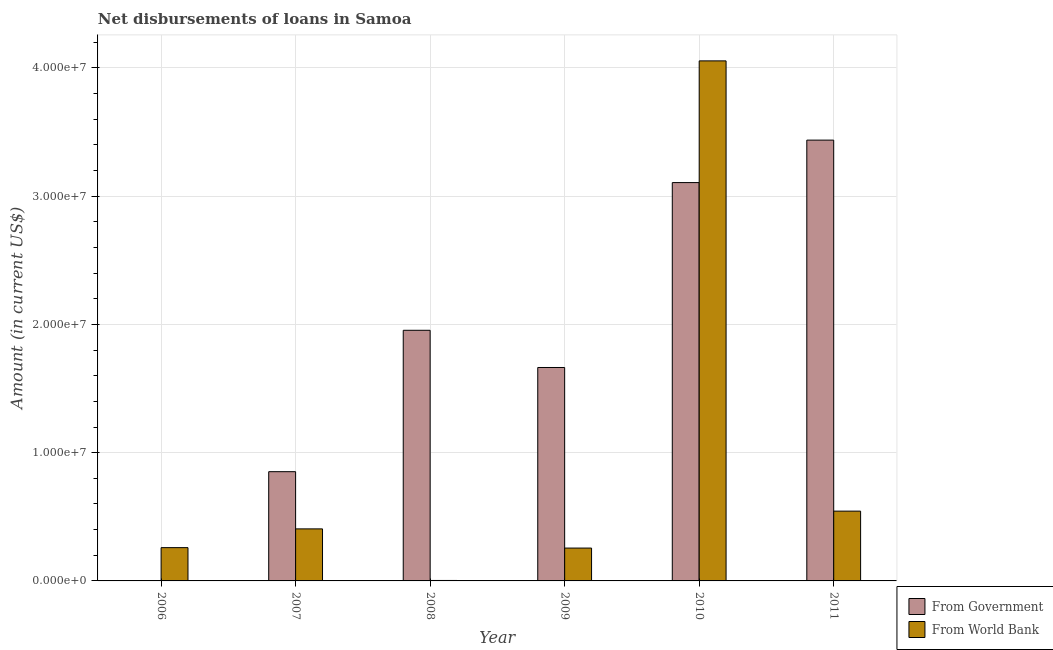Are the number of bars on each tick of the X-axis equal?
Make the answer very short. No. How many bars are there on the 1st tick from the right?
Provide a succinct answer. 2. What is the label of the 3rd group of bars from the left?
Make the answer very short. 2008. What is the net disbursements of loan from world bank in 2006?
Make the answer very short. 2.60e+06. Across all years, what is the maximum net disbursements of loan from world bank?
Keep it short and to the point. 4.05e+07. What is the total net disbursements of loan from world bank in the graph?
Provide a succinct answer. 5.52e+07. What is the difference between the net disbursements of loan from world bank in 2006 and that in 2009?
Offer a very short reply. 3.40e+04. What is the difference between the net disbursements of loan from government in 2010 and the net disbursements of loan from world bank in 2007?
Ensure brevity in your answer.  2.25e+07. What is the average net disbursements of loan from government per year?
Make the answer very short. 1.84e+07. In how many years, is the net disbursements of loan from world bank greater than 32000000 US$?
Your response must be concise. 1. What is the ratio of the net disbursements of loan from world bank in 2007 to that in 2011?
Offer a very short reply. 0.75. Is the net disbursements of loan from world bank in 2006 less than that in 2008?
Your answer should be compact. No. What is the difference between the highest and the second highest net disbursements of loan from world bank?
Your answer should be very brief. 3.51e+07. What is the difference between the highest and the lowest net disbursements of loan from world bank?
Your answer should be compact. 4.05e+07. In how many years, is the net disbursements of loan from government greater than the average net disbursements of loan from government taken over all years?
Offer a terse response. 3. Is the sum of the net disbursements of loan from world bank in 2007 and 2008 greater than the maximum net disbursements of loan from government across all years?
Your answer should be compact. No. Does the graph contain any zero values?
Provide a short and direct response. Yes. How many legend labels are there?
Ensure brevity in your answer.  2. How are the legend labels stacked?
Provide a short and direct response. Vertical. What is the title of the graph?
Offer a terse response. Net disbursements of loans in Samoa. What is the label or title of the X-axis?
Offer a very short reply. Year. What is the Amount (in current US$) in From World Bank in 2006?
Ensure brevity in your answer.  2.60e+06. What is the Amount (in current US$) in From Government in 2007?
Make the answer very short. 8.52e+06. What is the Amount (in current US$) in From World Bank in 2007?
Provide a short and direct response. 4.06e+06. What is the Amount (in current US$) of From Government in 2008?
Provide a succinct answer. 1.95e+07. What is the Amount (in current US$) in From World Bank in 2008?
Ensure brevity in your answer.  3.60e+04. What is the Amount (in current US$) in From Government in 2009?
Keep it short and to the point. 1.66e+07. What is the Amount (in current US$) in From World Bank in 2009?
Provide a short and direct response. 2.56e+06. What is the Amount (in current US$) of From Government in 2010?
Give a very brief answer. 3.11e+07. What is the Amount (in current US$) in From World Bank in 2010?
Keep it short and to the point. 4.05e+07. What is the Amount (in current US$) of From Government in 2011?
Ensure brevity in your answer.  3.44e+07. What is the Amount (in current US$) of From World Bank in 2011?
Your answer should be compact. 5.44e+06. Across all years, what is the maximum Amount (in current US$) of From Government?
Provide a succinct answer. 3.44e+07. Across all years, what is the maximum Amount (in current US$) of From World Bank?
Offer a terse response. 4.05e+07. Across all years, what is the minimum Amount (in current US$) of From World Bank?
Ensure brevity in your answer.  3.60e+04. What is the total Amount (in current US$) of From Government in the graph?
Offer a terse response. 1.10e+08. What is the total Amount (in current US$) of From World Bank in the graph?
Keep it short and to the point. 5.52e+07. What is the difference between the Amount (in current US$) in From World Bank in 2006 and that in 2007?
Offer a very short reply. -1.46e+06. What is the difference between the Amount (in current US$) in From World Bank in 2006 and that in 2008?
Offer a very short reply. 2.56e+06. What is the difference between the Amount (in current US$) of From World Bank in 2006 and that in 2009?
Your response must be concise. 3.40e+04. What is the difference between the Amount (in current US$) of From World Bank in 2006 and that in 2010?
Provide a succinct answer. -3.80e+07. What is the difference between the Amount (in current US$) of From World Bank in 2006 and that in 2011?
Offer a very short reply. -2.85e+06. What is the difference between the Amount (in current US$) of From Government in 2007 and that in 2008?
Your answer should be very brief. -1.10e+07. What is the difference between the Amount (in current US$) of From World Bank in 2007 and that in 2008?
Ensure brevity in your answer.  4.02e+06. What is the difference between the Amount (in current US$) of From Government in 2007 and that in 2009?
Offer a very short reply. -8.12e+06. What is the difference between the Amount (in current US$) of From World Bank in 2007 and that in 2009?
Offer a very short reply. 1.50e+06. What is the difference between the Amount (in current US$) of From Government in 2007 and that in 2010?
Provide a short and direct response. -2.25e+07. What is the difference between the Amount (in current US$) in From World Bank in 2007 and that in 2010?
Your response must be concise. -3.65e+07. What is the difference between the Amount (in current US$) in From Government in 2007 and that in 2011?
Your answer should be very brief. -2.59e+07. What is the difference between the Amount (in current US$) of From World Bank in 2007 and that in 2011?
Your answer should be compact. -1.38e+06. What is the difference between the Amount (in current US$) of From Government in 2008 and that in 2009?
Your answer should be compact. 2.90e+06. What is the difference between the Amount (in current US$) in From World Bank in 2008 and that in 2009?
Your answer should be compact. -2.52e+06. What is the difference between the Amount (in current US$) of From Government in 2008 and that in 2010?
Offer a terse response. -1.15e+07. What is the difference between the Amount (in current US$) in From World Bank in 2008 and that in 2010?
Your response must be concise. -4.05e+07. What is the difference between the Amount (in current US$) in From Government in 2008 and that in 2011?
Your answer should be very brief. -1.48e+07. What is the difference between the Amount (in current US$) of From World Bank in 2008 and that in 2011?
Your response must be concise. -5.40e+06. What is the difference between the Amount (in current US$) in From Government in 2009 and that in 2010?
Provide a succinct answer. -1.44e+07. What is the difference between the Amount (in current US$) in From World Bank in 2009 and that in 2010?
Your answer should be compact. -3.80e+07. What is the difference between the Amount (in current US$) in From Government in 2009 and that in 2011?
Give a very brief answer. -1.77e+07. What is the difference between the Amount (in current US$) of From World Bank in 2009 and that in 2011?
Your response must be concise. -2.88e+06. What is the difference between the Amount (in current US$) in From Government in 2010 and that in 2011?
Your response must be concise. -3.31e+06. What is the difference between the Amount (in current US$) in From World Bank in 2010 and that in 2011?
Make the answer very short. 3.51e+07. What is the difference between the Amount (in current US$) of From Government in 2007 and the Amount (in current US$) of From World Bank in 2008?
Offer a terse response. 8.48e+06. What is the difference between the Amount (in current US$) of From Government in 2007 and the Amount (in current US$) of From World Bank in 2009?
Provide a short and direct response. 5.96e+06. What is the difference between the Amount (in current US$) of From Government in 2007 and the Amount (in current US$) of From World Bank in 2010?
Your answer should be very brief. -3.20e+07. What is the difference between the Amount (in current US$) in From Government in 2007 and the Amount (in current US$) in From World Bank in 2011?
Ensure brevity in your answer.  3.08e+06. What is the difference between the Amount (in current US$) in From Government in 2008 and the Amount (in current US$) in From World Bank in 2009?
Give a very brief answer. 1.70e+07. What is the difference between the Amount (in current US$) of From Government in 2008 and the Amount (in current US$) of From World Bank in 2010?
Your answer should be compact. -2.10e+07. What is the difference between the Amount (in current US$) in From Government in 2008 and the Amount (in current US$) in From World Bank in 2011?
Your answer should be very brief. 1.41e+07. What is the difference between the Amount (in current US$) in From Government in 2009 and the Amount (in current US$) in From World Bank in 2010?
Offer a very short reply. -2.39e+07. What is the difference between the Amount (in current US$) of From Government in 2009 and the Amount (in current US$) of From World Bank in 2011?
Your answer should be very brief. 1.12e+07. What is the difference between the Amount (in current US$) in From Government in 2010 and the Amount (in current US$) in From World Bank in 2011?
Your answer should be compact. 2.56e+07. What is the average Amount (in current US$) in From Government per year?
Your response must be concise. 1.84e+07. What is the average Amount (in current US$) of From World Bank per year?
Your response must be concise. 9.21e+06. In the year 2007, what is the difference between the Amount (in current US$) of From Government and Amount (in current US$) of From World Bank?
Provide a short and direct response. 4.46e+06. In the year 2008, what is the difference between the Amount (in current US$) of From Government and Amount (in current US$) of From World Bank?
Ensure brevity in your answer.  1.95e+07. In the year 2009, what is the difference between the Amount (in current US$) of From Government and Amount (in current US$) of From World Bank?
Your answer should be compact. 1.41e+07. In the year 2010, what is the difference between the Amount (in current US$) in From Government and Amount (in current US$) in From World Bank?
Make the answer very short. -9.49e+06. In the year 2011, what is the difference between the Amount (in current US$) in From Government and Amount (in current US$) in From World Bank?
Provide a short and direct response. 2.89e+07. What is the ratio of the Amount (in current US$) in From World Bank in 2006 to that in 2007?
Your answer should be very brief. 0.64. What is the ratio of the Amount (in current US$) in From World Bank in 2006 to that in 2008?
Offer a terse response. 72.08. What is the ratio of the Amount (in current US$) in From World Bank in 2006 to that in 2009?
Provide a succinct answer. 1.01. What is the ratio of the Amount (in current US$) in From World Bank in 2006 to that in 2010?
Your response must be concise. 0.06. What is the ratio of the Amount (in current US$) of From World Bank in 2006 to that in 2011?
Ensure brevity in your answer.  0.48. What is the ratio of the Amount (in current US$) of From Government in 2007 to that in 2008?
Offer a very short reply. 0.44. What is the ratio of the Amount (in current US$) in From World Bank in 2007 to that in 2008?
Offer a terse response. 112.69. What is the ratio of the Amount (in current US$) in From Government in 2007 to that in 2009?
Offer a very short reply. 0.51. What is the ratio of the Amount (in current US$) in From World Bank in 2007 to that in 2009?
Keep it short and to the point. 1.58. What is the ratio of the Amount (in current US$) in From Government in 2007 to that in 2010?
Your answer should be very brief. 0.27. What is the ratio of the Amount (in current US$) of From World Bank in 2007 to that in 2010?
Provide a succinct answer. 0.1. What is the ratio of the Amount (in current US$) of From Government in 2007 to that in 2011?
Keep it short and to the point. 0.25. What is the ratio of the Amount (in current US$) of From World Bank in 2007 to that in 2011?
Your answer should be very brief. 0.75. What is the ratio of the Amount (in current US$) in From Government in 2008 to that in 2009?
Your answer should be very brief. 1.17. What is the ratio of the Amount (in current US$) of From World Bank in 2008 to that in 2009?
Your answer should be compact. 0.01. What is the ratio of the Amount (in current US$) of From Government in 2008 to that in 2010?
Offer a terse response. 0.63. What is the ratio of the Amount (in current US$) of From World Bank in 2008 to that in 2010?
Your answer should be compact. 0. What is the ratio of the Amount (in current US$) of From Government in 2008 to that in 2011?
Keep it short and to the point. 0.57. What is the ratio of the Amount (in current US$) in From World Bank in 2008 to that in 2011?
Offer a terse response. 0.01. What is the ratio of the Amount (in current US$) in From Government in 2009 to that in 2010?
Your answer should be very brief. 0.54. What is the ratio of the Amount (in current US$) in From World Bank in 2009 to that in 2010?
Give a very brief answer. 0.06. What is the ratio of the Amount (in current US$) of From Government in 2009 to that in 2011?
Your response must be concise. 0.48. What is the ratio of the Amount (in current US$) of From World Bank in 2009 to that in 2011?
Make the answer very short. 0.47. What is the ratio of the Amount (in current US$) of From Government in 2010 to that in 2011?
Provide a succinct answer. 0.9. What is the ratio of the Amount (in current US$) of From World Bank in 2010 to that in 2011?
Provide a short and direct response. 7.45. What is the difference between the highest and the second highest Amount (in current US$) of From Government?
Make the answer very short. 3.31e+06. What is the difference between the highest and the second highest Amount (in current US$) of From World Bank?
Make the answer very short. 3.51e+07. What is the difference between the highest and the lowest Amount (in current US$) of From Government?
Make the answer very short. 3.44e+07. What is the difference between the highest and the lowest Amount (in current US$) of From World Bank?
Provide a succinct answer. 4.05e+07. 